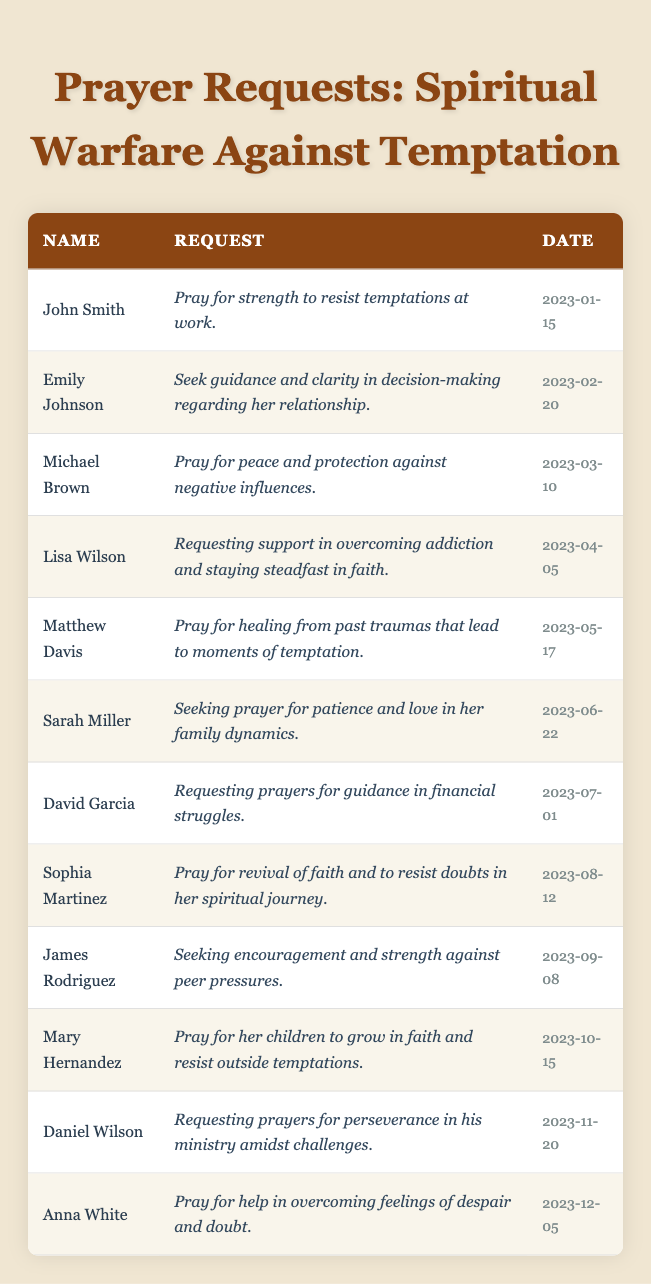What is the prayer request from John Smith? The table lists the prayer request associated with John Smith. If we look under the "Request" column for John Smith's row, we find that he is asking for strength to resist temptations at work.
Answer: Strength to resist temptations at work How many prayer requests were made in March 2023? To find the number of requests in March, we count the entries for that month in the "Date" column. There's one request from Michael Brown on March 10.
Answer: 1 What common theme do the requests from Mary Hernandez and Sophia Martinez share? Analyzing both requests, Mary Hernandez asks for prayers for her children to grow in faith and resist temptations, while Sophia Martinez requests prayer for revival of faith and to resist doubts. The common theme is the focus on resisting negative influences and strengthening faith.
Answer: Resisting negative influences and strengthening faith Who requested prayer for healing from past traumas? The table indicates that Matthew Davis requested prayer for healing from past traumas that lead to moments of temptation. We can find this information directly under his corresponding row.
Answer: Matthew Davis Which month has the least number of requests in the table? To determine the month with the least requests, we need to count the number of requests per month listed. After analyzing the dates, each month from January to December has one request, showing them evenly distributed.
Answer: All months have one request How many requests mention guidance or clarity? By reviewing the requests, we identify who mentions guidance or clarity: Emily Johnson requests clarity in decision-making, and David Garcia asks for guidance in financial struggles. We count these two requests.
Answer: 2 What is the primary concern of Lisa Wilson's prayer request? Looking at Lisa Wilson's request, she is asking for support in overcoming addiction and staying steadfast in her faith. This reflects a primary concern for both personal struggle and spiritual perseverance.
Answer: Overcoming addiction and staying steadfast in faith Which request was made most recently, and what is it about? To find the most recent request, we check the "Date" column and see that Anna White's request on December 5, 2023, is the latest. Her request is related to overcoming feelings of despair and doubt.
Answer: Anna White's request about overcoming despair and doubt Can you summarize the number of requests related to family? By checking the table, we find two relevant requests: Sarah Miller seeks prayer for patience and love in family dynamics, and Mary Hernandez asks for her children to grow in faith. Thus, we count these two requests.
Answer: 2 Is there a request for prayer connected to youth or children? Mary Hernandez specifically requests prayer for her children to grow in faith, aligning this request with a focus on youth and children's spiritual development.
Answer: Yes, there is one 